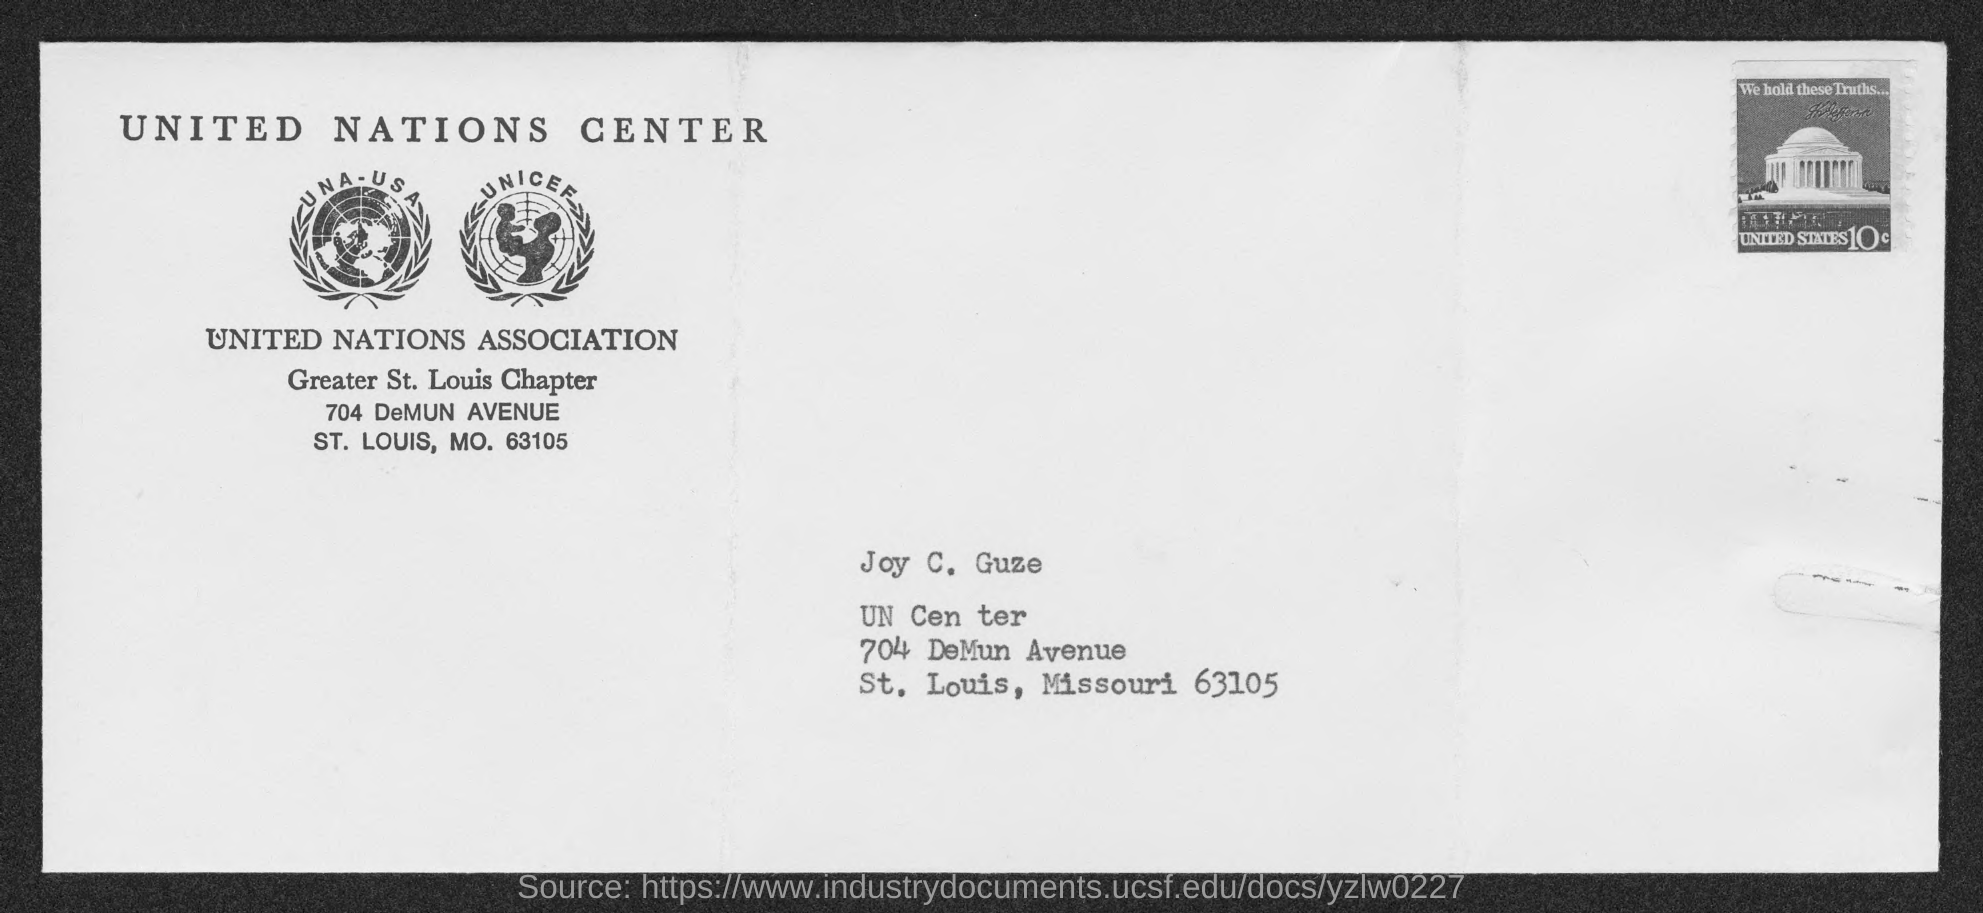List a handful of essential elements in this visual. The person mentioned in the address is Joy C. Guze. 